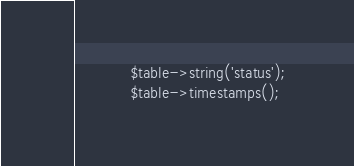<code> <loc_0><loc_0><loc_500><loc_500><_PHP_>            $table->string('status'); 
            $table->timestamps();</code> 